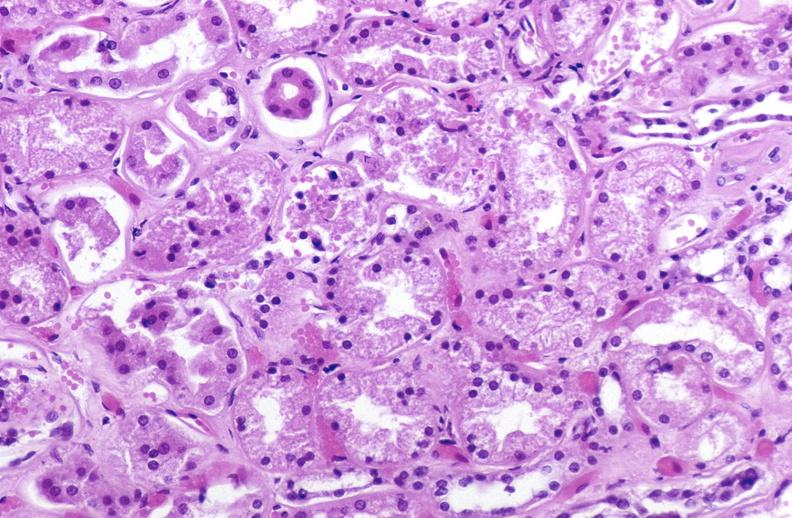does linear fracture in occiput show atn acute tubular necrosis?
Answer the question using a single word or phrase. No 